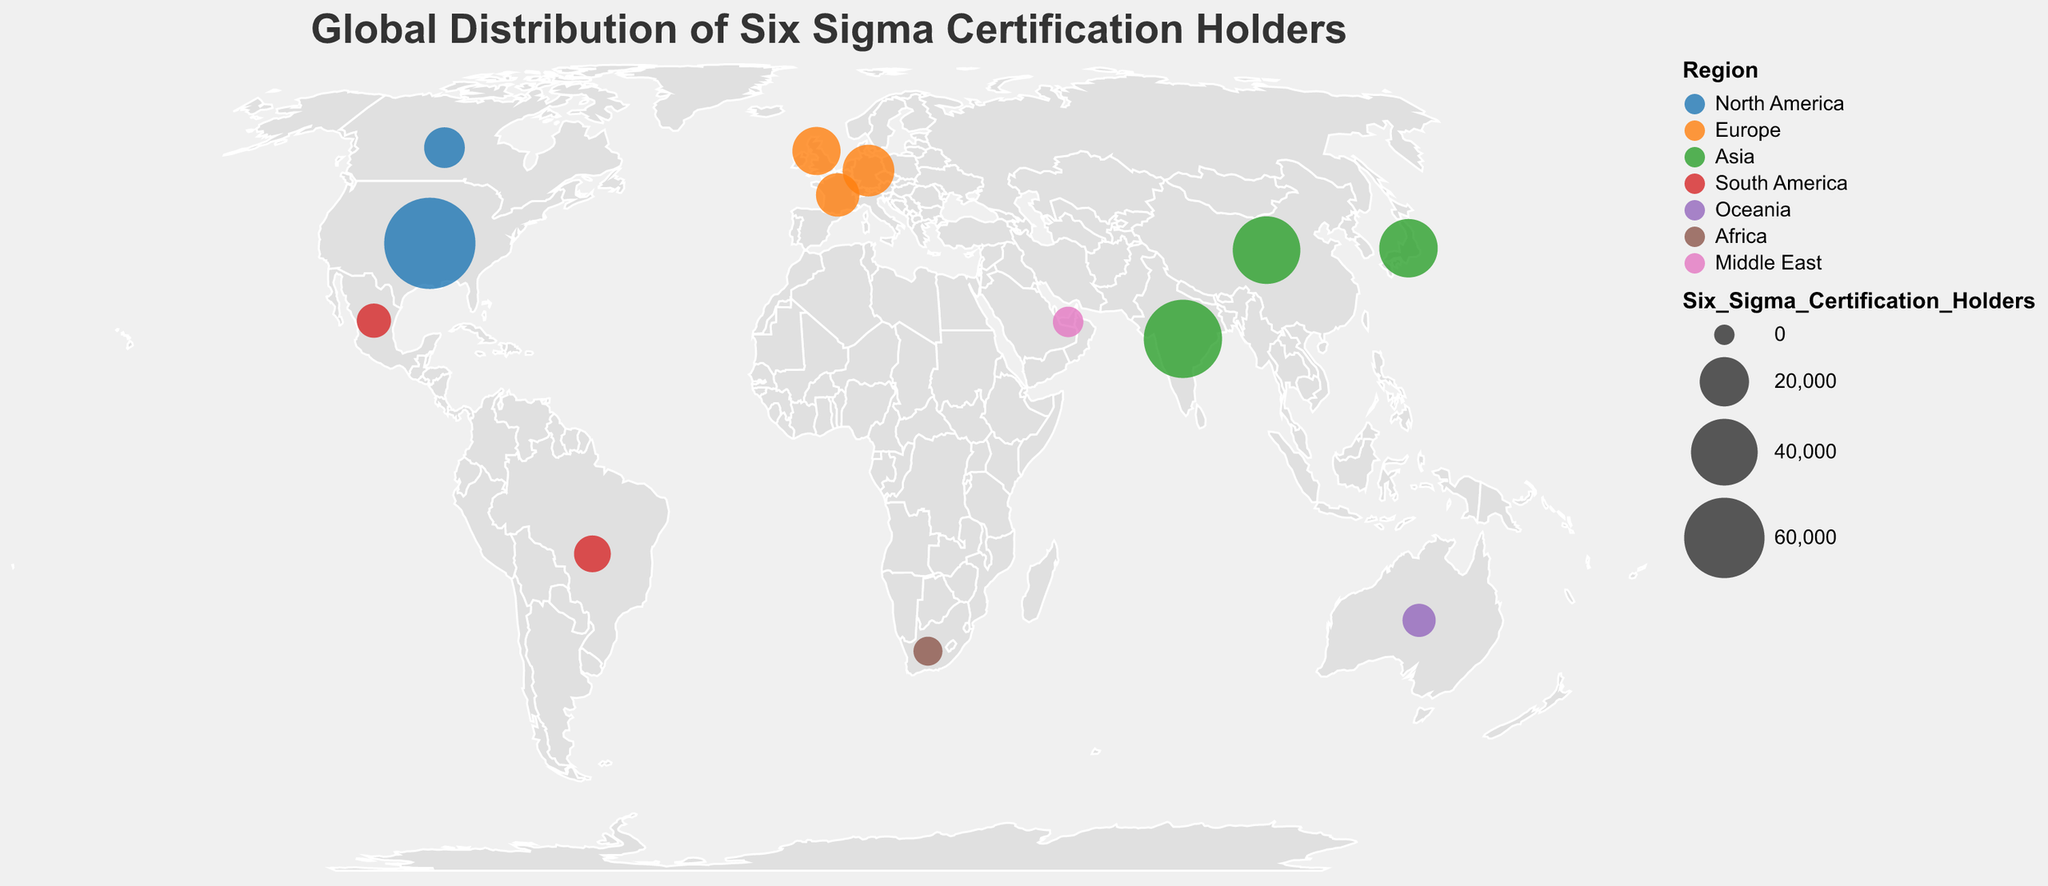What is the title of the figure? The title of the figure is prominently displayed at the top.
Answer: Global Distribution of Six Sigma Certification Holders Which region has the highest number of Six Sigma certification holders? By identifying the largest circle and noting its color, we see that the United States in North America has the most certification holders.
Answer: North America How many Six Sigma certification holders are there in Japan? Locate the circle for Japan, and the tooltip reveals the number of certification holders.
Answer: 29,800 What is the total number of Six Sigma certification holders in Europe? Sum the holders in the United Kingdom, Germany, and France: 18,900 + 22,400 + 14,600.
Answer: 55,900 Which country in South America has more Six Sigma certification holders? Compare the circle sizes and/or tooltip values for Brazil and Mexico.
Answer: Brazil How does the number of Six Sigma certification holders in China compare to India? Look at the tooltip values or circle sizes for China and India. China has 41,200, while India has 56,700.
Answer: India has more Which regions have fewer than 10,000 Six Sigma certification holders? Identify the regions with small circles or tooltip values below 10,000. South America (Brazil and Mexico), Oceania (Australia), Africa (South Africa), and Middle East (United Arab Emirates).
Answer: South America, Oceania, Africa, Middle East What is the average number of Six Sigma certification holders across all continents? Sum all certification holders and divide by the number of data points (13 countries): (78500 + 12300 + 18900 + 22400 + 14600 + 56700 + 41200 + 29800 + 9300 + 7500 + 6800 + 4200 + 5100) / 13.
Answer: 25,738 Which country's circle is the smallest in the plot, and what is its region? By identifying the smallest circle and referring to the tooltip, it is South Africa in the Africa region.
Answer: South Africa, Africa 